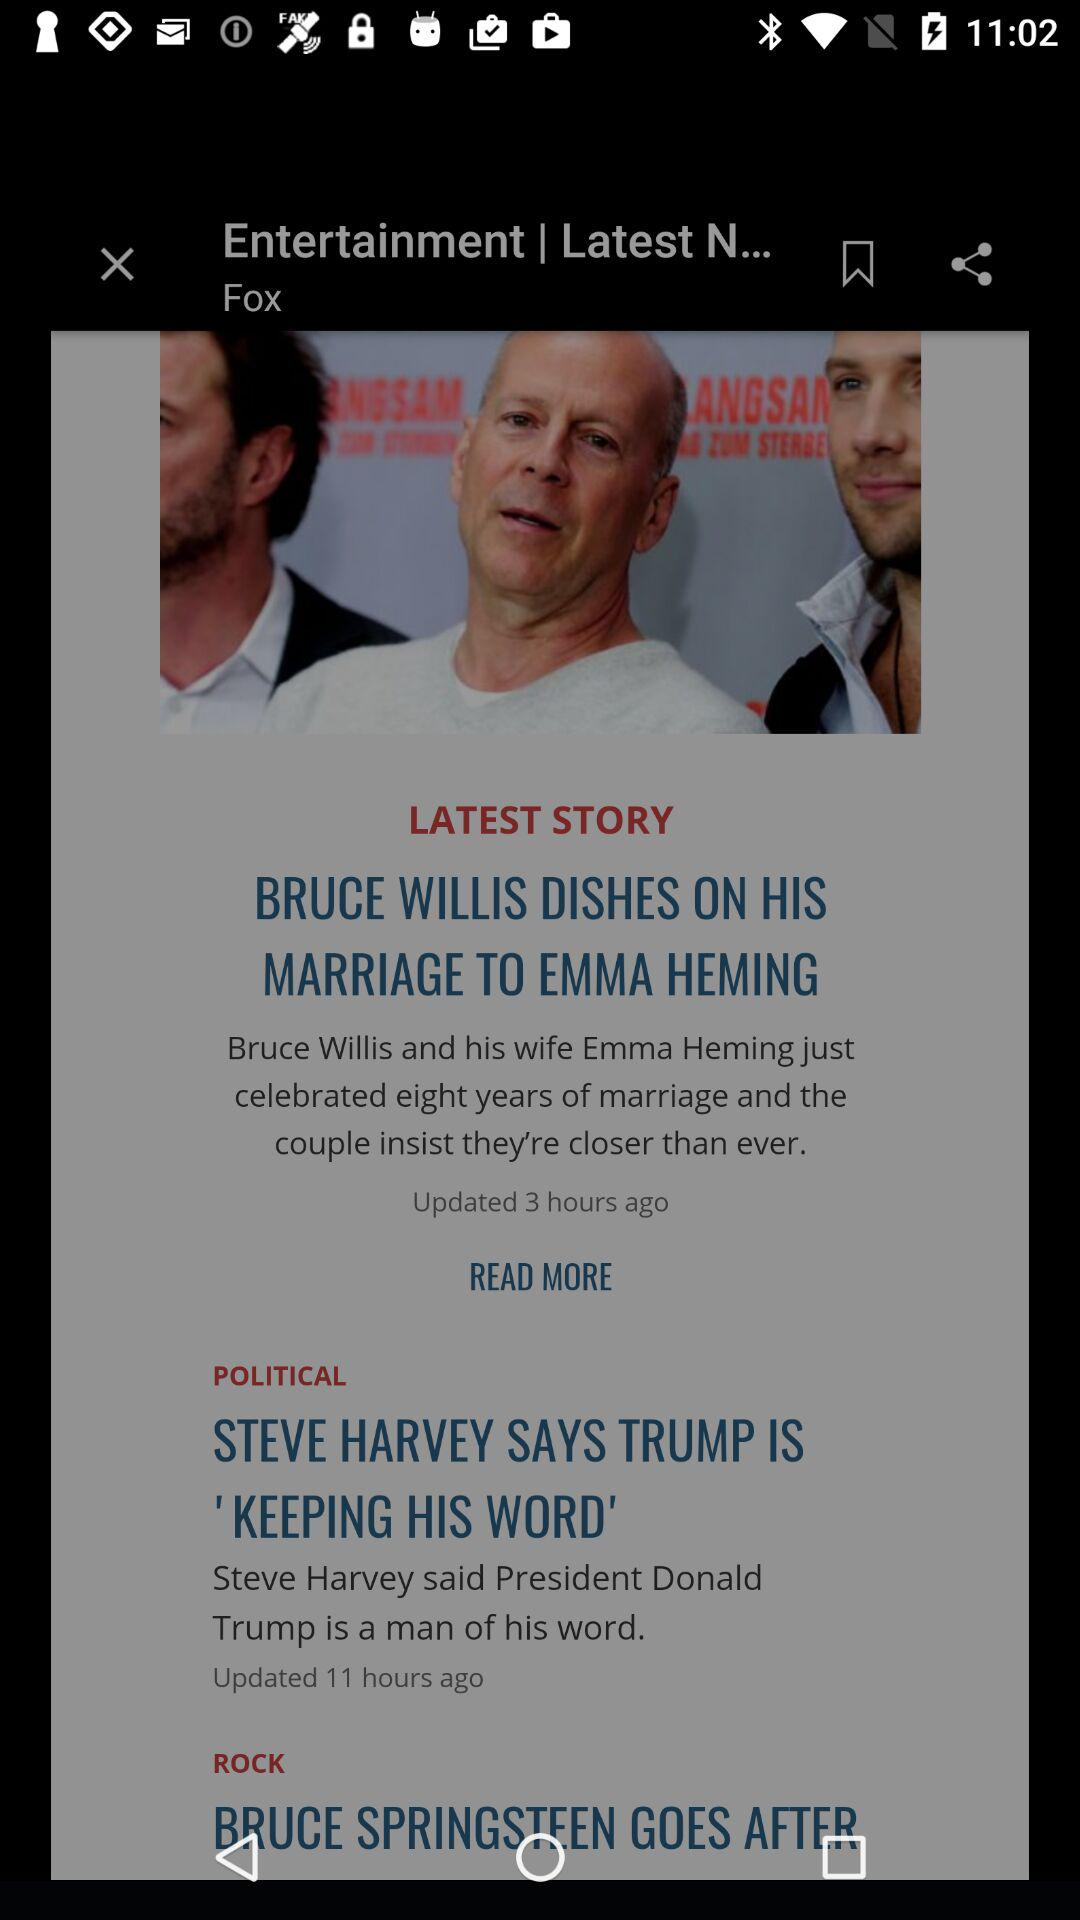How many stories are in the Entertainment section?
Answer the question using a single word or phrase. 1 